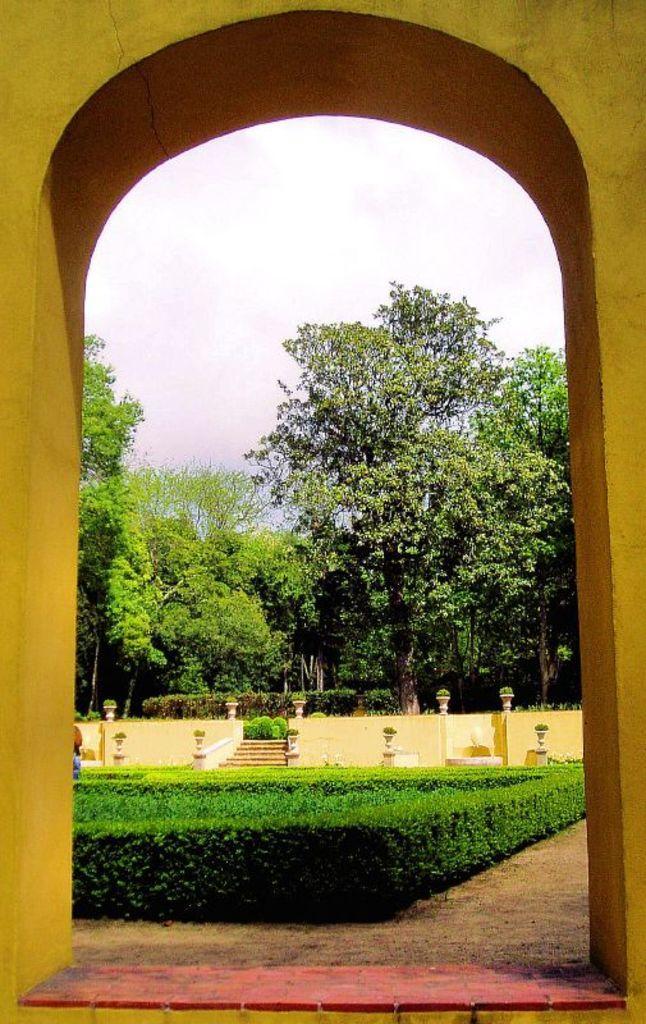Can you describe this image briefly? In the center of the image we can see the trees, stairs, wall, poles, bushes. In the background of the image we can see an arch. At the top of the image we can see the sky. At the bottom of the image we can see the ground, floor. 